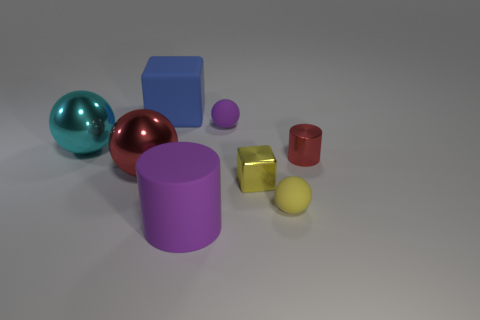Subtract all brown balls. Subtract all gray cylinders. How many balls are left? 4 Add 1 small green metal balls. How many objects exist? 9 Subtract all cubes. How many objects are left? 6 Add 2 purple rubber objects. How many purple rubber objects are left? 4 Add 3 tiny red objects. How many tiny red objects exist? 4 Subtract 0 yellow cylinders. How many objects are left? 8 Subtract all small metallic things. Subtract all shiny cylinders. How many objects are left? 5 